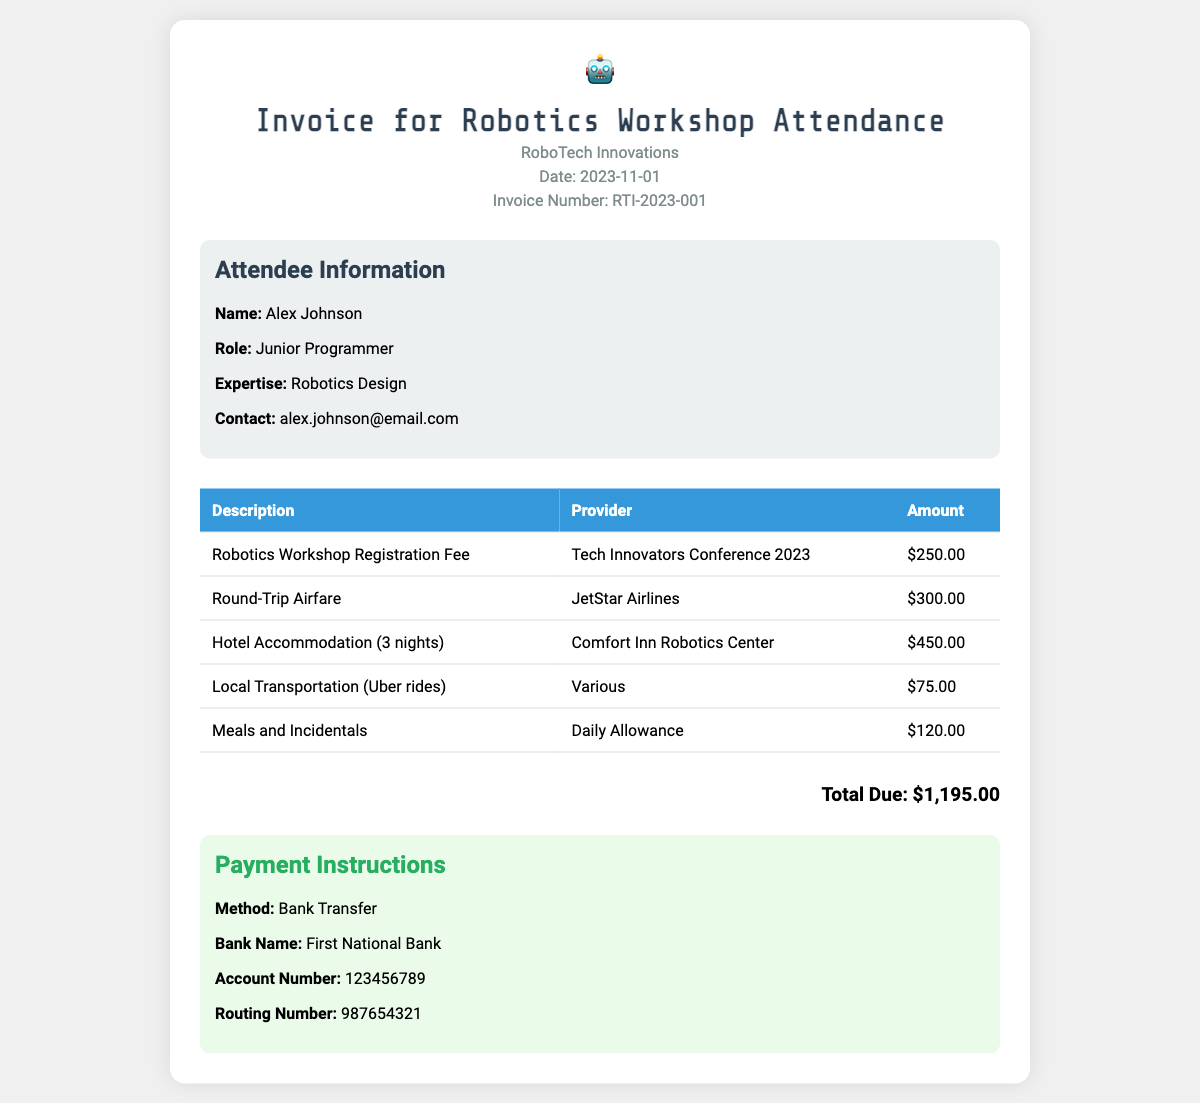What is the invoice number? The invoice number can be found in the header of the document, which states "Invoice Number: RTI-2023-001".
Answer: RTI-2023-001 What is the total due amount? The total due amount is indicated at the bottom of the invoice, which shows "Total Due: $1,195.00".
Answer: $1,195.00 Who is the attendee? The attendee's name is listed in the attendee information section, which states "Name: Alex Johnson".
Answer: Alex Johnson How many nights was the hotel accommodation for? The hotel accommodation line explains "Hotel Accommodation (3 nights)", indicating the duration.
Answer: 3 nights What is the source of the registration fee? The source of the registration fee is mentioned in the itemized list, specifically "Tech Innovators Conference 2023".
Answer: Tech Innovators Conference 2023 What type of payment method is specified? The payment method can be found in the payment instructions section, which mentions "Method: Bank Transfer".
Answer: Bank Transfer What was the airfare amount? The airfare amount is explicitly listed in the table as "$300.00" under "Round-Trip Airfare".
Answer: $300.00 What provider supplied the local transportation? The provider for local transportation is noted as "Various" in the itemized expenses.
Answer: Various 